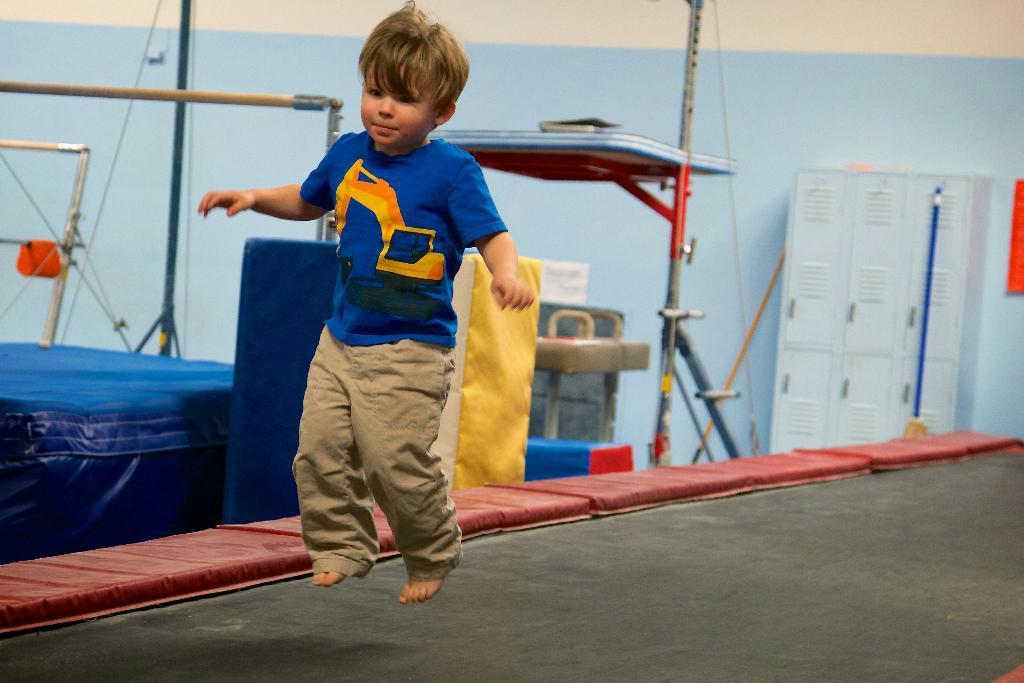Describe this image in one or two sentences. In the center of the image there is a boy in the air. In the background we can see cupboards, poles, wires and wall. 